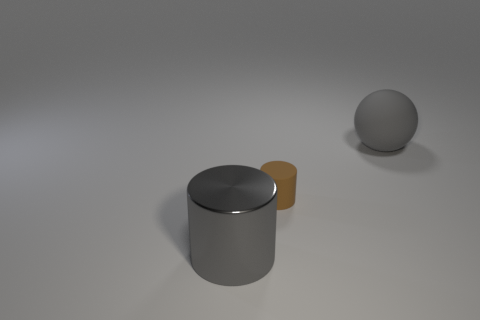Are there any other things that have the same size as the brown matte cylinder?
Provide a short and direct response. No. How many things are big gray metallic cylinders or large objects that are in front of the tiny matte object?
Offer a terse response. 1. How big is the gray object that is behind the gray object in front of the small rubber cylinder?
Provide a succinct answer. Large. Is the number of gray things behind the gray rubber sphere the same as the number of metal things on the left side of the large gray metallic object?
Give a very brief answer. Yes. There is a metal cylinder that is in front of the brown matte thing; are there any cylinders that are behind it?
Offer a very short reply. Yes. What is the shape of the big gray object that is made of the same material as the small brown cylinder?
Provide a succinct answer. Sphere. Are there any other things that are the same color as the sphere?
Make the answer very short. Yes. What is the material of the big thing in front of the large thing behind the brown thing?
Keep it short and to the point. Metal. Are there any gray objects that have the same shape as the small brown rubber thing?
Make the answer very short. Yes. What number of other objects are there of the same shape as the brown rubber thing?
Your answer should be very brief. 1. 